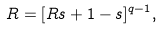Convert formula to latex. <formula><loc_0><loc_0><loc_500><loc_500>R = [ R s + 1 - s ] ^ { q - 1 } ,</formula> 